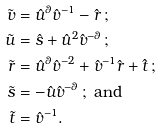Convert formula to latex. <formula><loc_0><loc_0><loc_500><loc_500>\tilde { v } & = \hat { u } ^ { \theta } \hat { v } ^ { - 1 } - \hat { r } \, ; \\ \tilde { u } & = \hat { s } + \hat { u } ^ { 2 } \hat { v } ^ { - \theta } \, ; \\ \tilde { r } & = \hat { u } ^ { \theta } \hat { v } ^ { - 2 } + \hat { v } ^ { - 1 } \hat { r } + \hat { t } \, ; \\ \tilde { s } & = - \hat { u } \hat { v } ^ { - \theta } \, ; \text { and} \\ \tilde { t } & = \hat { v } ^ { - 1 } .</formula> 